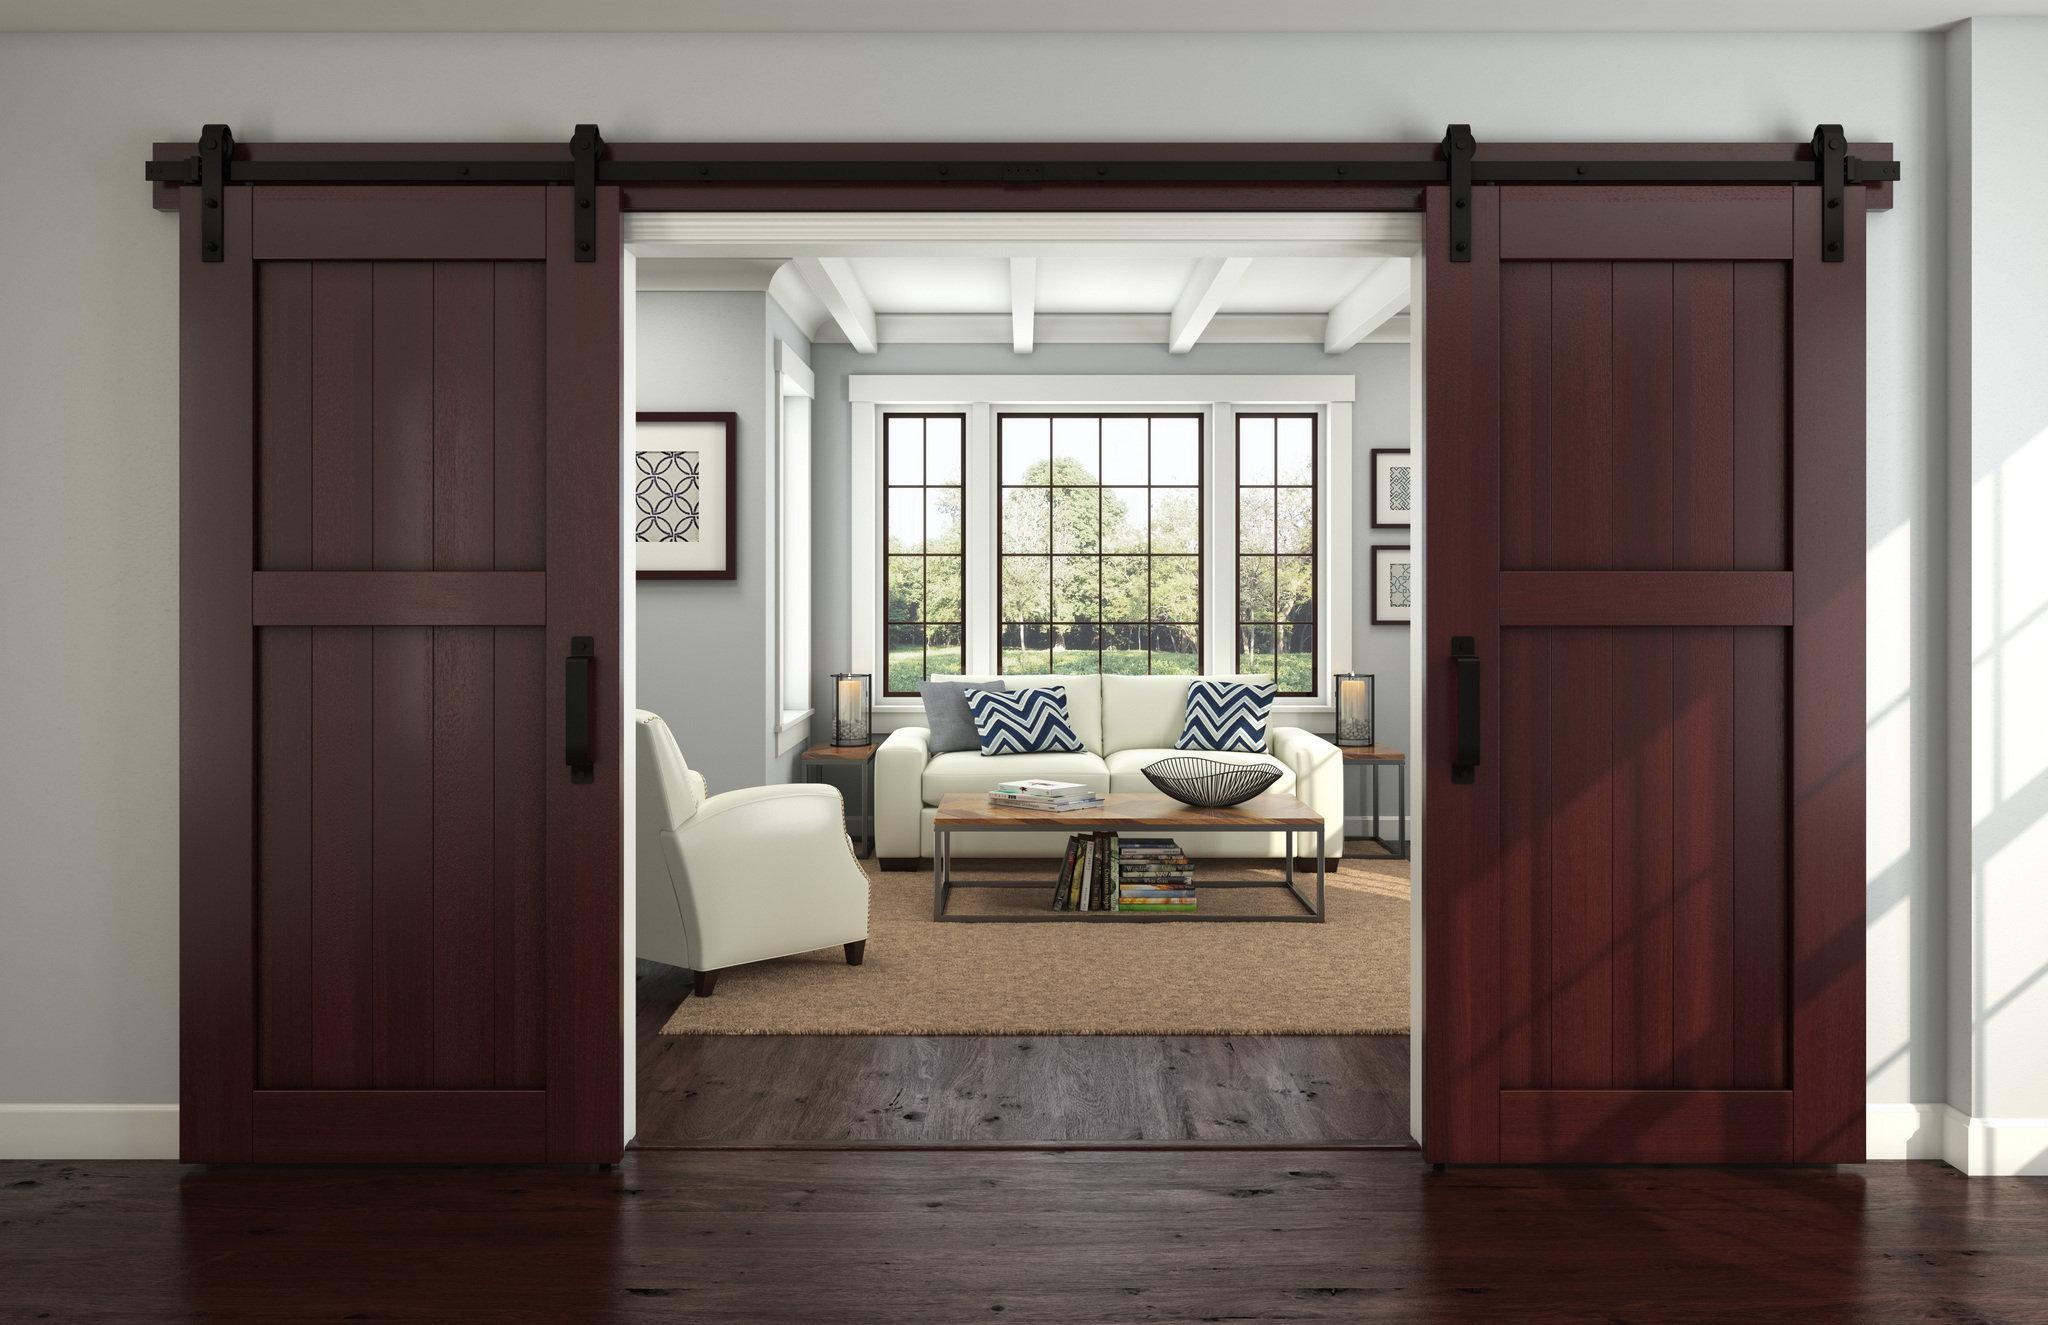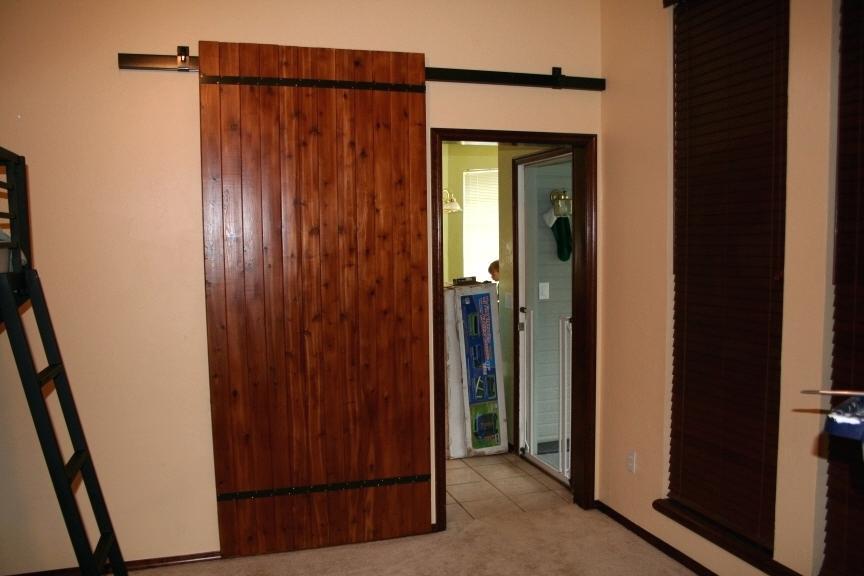The first image is the image on the left, the second image is the image on the right. Evaluate the accuracy of this statement regarding the images: "The left image features a wide-open sliding 'barn style' wooden double door with a black bar at the top, and the right image shows a single barn-style wood plank door.". Is it true? Answer yes or no. Yes. The first image is the image on the left, the second image is the image on the right. Considering the images on both sides, is "The left and right image contains a total of three brown wooden hanging doors." valid? Answer yes or no. Yes. The first image is the image on the left, the second image is the image on the right. Examine the images to the left and right. Is the description "The left image features a 'barn style' wood-paneled double door with a black bar at the top, and the right image shows a single barn-style wood plank door." accurate? Answer yes or no. Yes. The first image is the image on the left, the second image is the image on the right. Considering the images on both sides, is "The left and right image contains a total of three brown wooden hanging doors." valid? Answer yes or no. Yes. 